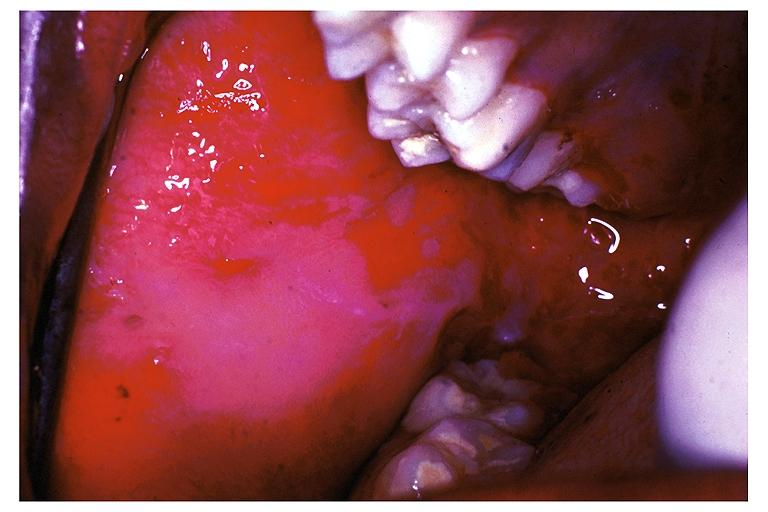s oral present?
Answer the question using a single word or phrase. Yes 